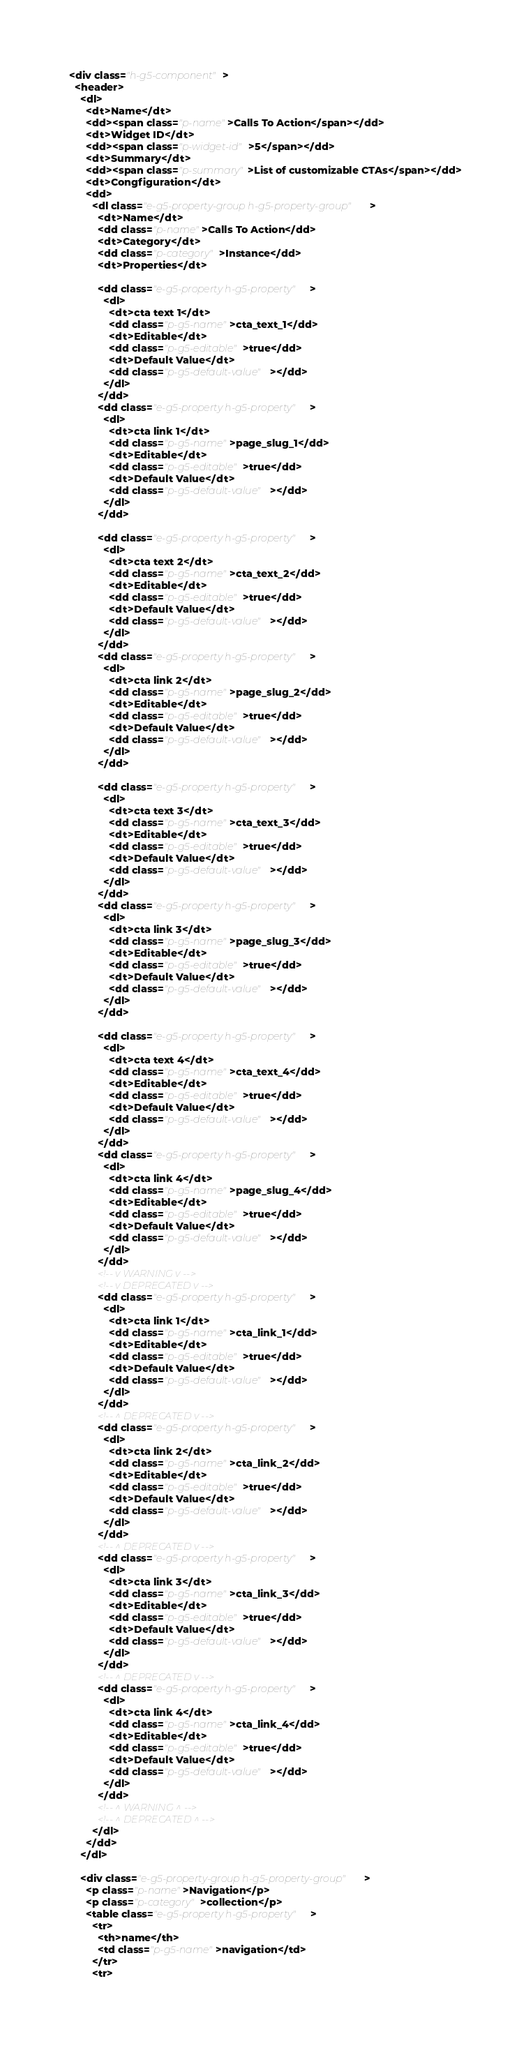Convert code to text. <code><loc_0><loc_0><loc_500><loc_500><_HTML_><div class="h-g5-component">
  <header>
    <dl>
      <dt>Name</dt>
      <dd><span class="p-name">Calls To Action</span></dd>
      <dt>Widget ID</dt>
      <dd><span class="p-widget-id">5</span></dd>
      <dt>Summary</dt>
      <dd><span class="p-summary">List of customizable CTAs</span></dd>
      <dt>Congfiguration</dt>
      <dd>
        <dl class="e-g5-property-group h-g5-property-group">
          <dt>Name</dt>
          <dd class="p-name">Calls To Action</dd>
          <dt>Category</dt>
          <dd class="p-category">Instance</dd>
          <dt>Properties</dt>
          
          <dd class="e-g5-property h-g5-property">
            <dl>
              <dt>cta text 1</dt>
              <dd class="p-g5-name">cta_text_1</dd>
              <dt>Editable</dt>
              <dd class="p-g5-editable">true</dd>
              <dt>Default Value</dt>
              <dd class="p-g5-default-value"></dd>
            </dl>
          </dd>    
          <dd class="e-g5-property h-g5-property">
            <dl>
              <dt>cta link 1</dt>
              <dd class="p-g5-name">page_slug_1</dd>
              <dt>Editable</dt>
              <dd class="p-g5-editable">true</dd>
              <dt>Default Value</dt>
              <dd class="p-g5-default-value"></dd>
            </dl>
          </dd>

          <dd class="e-g5-property h-g5-property">
            <dl>
              <dt>cta text 2</dt>
              <dd class="p-g5-name">cta_text_2</dd>
              <dt>Editable</dt>
              <dd class="p-g5-editable">true</dd>
              <dt>Default Value</dt>
              <dd class="p-g5-default-value"></dd>
            </dl>
          </dd>    
          <dd class="e-g5-property h-g5-property">
            <dl>
              <dt>cta link 2</dt>
              <dd class="p-g5-name">page_slug_2</dd>
              <dt>Editable</dt>
              <dd class="p-g5-editable">true</dd>
              <dt>Default Value</dt>
              <dd class="p-g5-default-value"></dd>
            </dl>
          </dd>

          <dd class="e-g5-property h-g5-property">
            <dl>
              <dt>cta text 3</dt>
              <dd class="p-g5-name">cta_text_3</dd>
              <dt>Editable</dt>
              <dd class="p-g5-editable">true</dd>
              <dt>Default Value</dt>
              <dd class="p-g5-default-value"></dd>
            </dl>
          </dd>    
          <dd class="e-g5-property h-g5-property">
            <dl>
              <dt>cta link 3</dt>
              <dd class="p-g5-name">page_slug_3</dd>
              <dt>Editable</dt>
              <dd class="p-g5-editable">true</dd>
              <dt>Default Value</dt>
              <dd class="p-g5-default-value"></dd>
            </dl>
          </dd>

          <dd class="e-g5-property h-g5-property">
            <dl>
              <dt>cta text 4</dt>
              <dd class="p-g5-name">cta_text_4</dd>
              <dt>Editable</dt>
              <dd class="p-g5-editable">true</dd>
              <dt>Default Value</dt>
              <dd class="p-g5-default-value"></dd>
            </dl>
          </dd>    
          <dd class="e-g5-property h-g5-property">
            <dl>
              <dt>cta link 4</dt>
              <dd class="p-g5-name">page_slug_4</dd>
              <dt>Editable</dt>
              <dd class="p-g5-editable">true</dd>
              <dt>Default Value</dt>
              <dd class="p-g5-default-value"></dd>
            </dl>
          </dd>
          <!-- v WARNING v -->
          <!-- v DEPRECATED v -->
          <dd class="e-g5-property h-g5-property">
            <dl>
              <dt>cta link 1</dt>
              <dd class="p-g5-name">cta_link_1</dd>
              <dt>Editable</dt>
              <dd class="p-g5-editable">true</dd>
              <dt>Default Value</dt>
              <dd class="p-g5-default-value"></dd>
            </dl>
          </dd>
          <!-- ^ DEPRECATED v -->
          <dd class="e-g5-property h-g5-property">
            <dl>
              <dt>cta link 2</dt>
              <dd class="p-g5-name">cta_link_2</dd>
              <dt>Editable</dt>
              <dd class="p-g5-editable">true</dd>
              <dt>Default Value</dt>
              <dd class="p-g5-default-value"></dd>
            </dl>
          </dd>
          <!-- ^ DEPRECATED v -->
          <dd class="e-g5-property h-g5-property">
            <dl>
              <dt>cta link 3</dt>
              <dd class="p-g5-name">cta_link_3</dd>
              <dt>Editable</dt>
              <dd class="p-g5-editable">true</dd>
              <dt>Default Value</dt>
              <dd class="p-g5-default-value"></dd>
            </dl>
          </dd>
          <!-- ^ DEPRECATED v -->
          <dd class="e-g5-property h-g5-property">
            <dl>
              <dt>cta link 4</dt>
              <dd class="p-g5-name">cta_link_4</dd>
              <dt>Editable</dt>
              <dd class="p-g5-editable">true</dd>
              <dt>Default Value</dt>
              <dd class="p-g5-default-value"></dd>
            </dl>
          </dd>
          <!-- ^ WARNING ^ -->
          <!-- ^ DEPRECATED ^ -->
        </dl>
      </dd>
    </dl>

    <div class="e-g5-property-group h-g5-property-group">
      <p class="p-name">Navigation</p>
      <p class="p-category">collection</p>
      <table class="e-g5-property h-g5-property">
        <tr>
          <th>name</th>
          <td class="p-g5-name">navigation</td>
        </tr>
        <tr></code> 